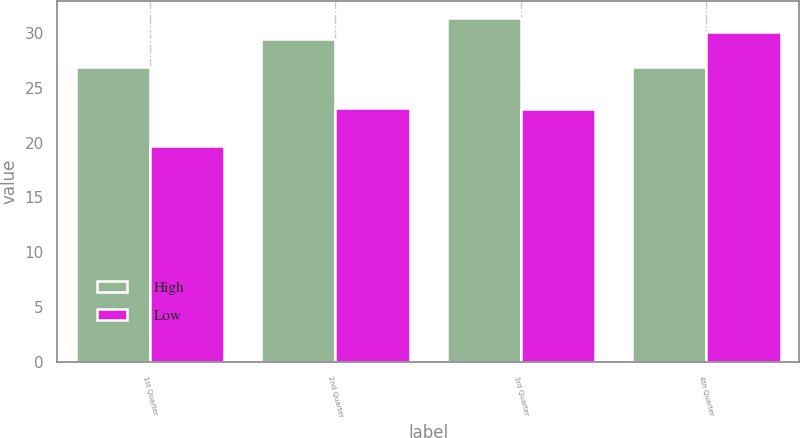<chart> <loc_0><loc_0><loc_500><loc_500><stacked_bar_chart><ecel><fcel>1st Quarter<fcel>2nd Quarter<fcel>3rd Quarter<fcel>4th Quarter<nl><fcel>High<fcel>26.91<fcel>29.46<fcel>31.35<fcel>26.91<nl><fcel>Low<fcel>19.65<fcel>23.14<fcel>23.02<fcel>30.07<nl></chart> 